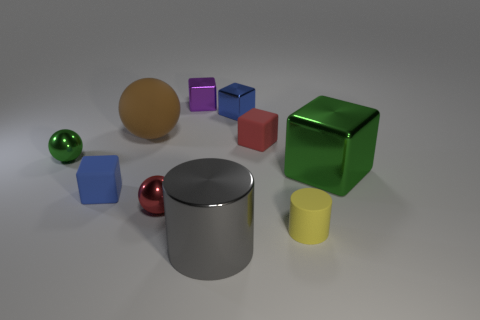Subtract all shiny blocks. How many blocks are left? 2 Subtract all blue cylinders. How many blue blocks are left? 2 Subtract all blue cubes. How many cubes are left? 3 Subtract 1 spheres. How many spheres are left? 2 Add 8 small brown cylinders. How many small brown cylinders exist? 8 Subtract 1 red cubes. How many objects are left? 9 Subtract all balls. How many objects are left? 7 Subtract all gray cubes. Subtract all purple cylinders. How many cubes are left? 5 Subtract all cubes. Subtract all small blue rubber blocks. How many objects are left? 4 Add 4 blue metal things. How many blue metal things are left? 5 